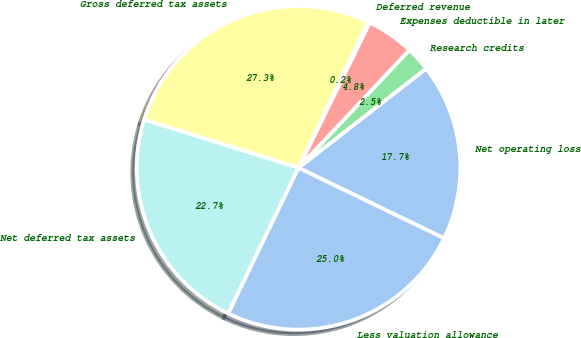Convert chart. <chart><loc_0><loc_0><loc_500><loc_500><pie_chart><fcel>Net operating loss<fcel>Research credits<fcel>Expenses deductible in later<fcel>Deferred revenue<fcel>Gross deferred tax assets<fcel>Net deferred tax assets<fcel>Less valuation allowance<nl><fcel>17.7%<fcel>2.46%<fcel>4.76%<fcel>0.17%<fcel>27.27%<fcel>22.67%<fcel>24.97%<nl></chart> 